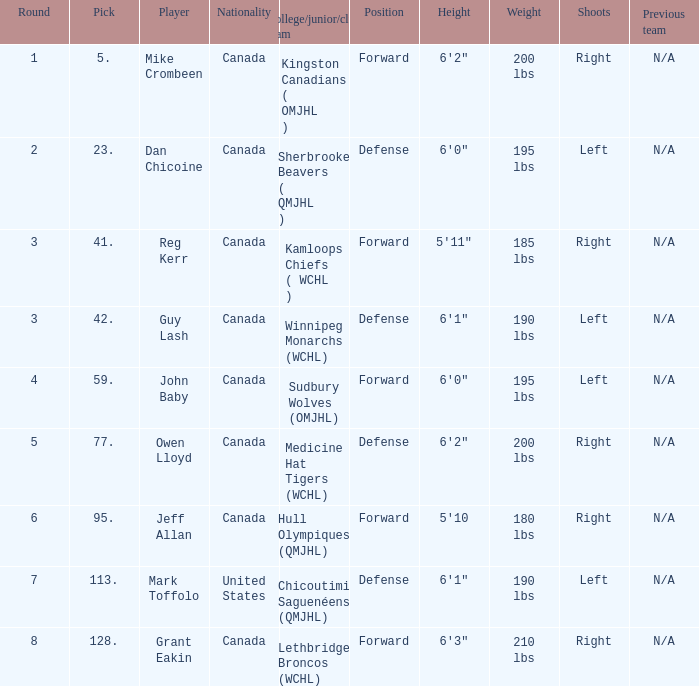Which Round has a Player of dan chicoine, and a Pick larger than 23? None. 